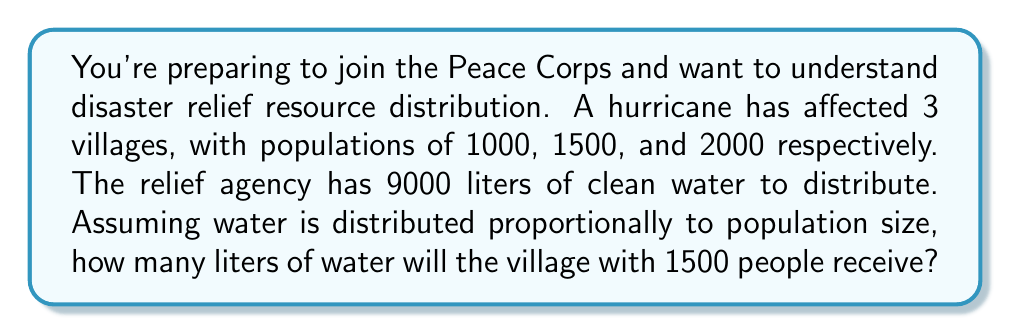Can you answer this question? Let's approach this step-by-step:

1) First, calculate the total population:
   $1000 + 1500 + 2000 = 4500$ people

2) Find the proportion of the total population in the village with 1500 people:
   $\frac{1500}{4500} = \frac{1}{3}$

3) Since water is distributed proportionally to population size, this village should receive $\frac{1}{3}$ of the total water supply.

4) Calculate $\frac{1}{3}$ of the total water supply:
   $$\frac{1}{3} \times 9000 = 3000$$ liters

Therefore, the village with 1500 people will receive 3000 liters of water.
Answer: 3000 liters 